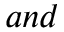<formula> <loc_0><loc_0><loc_500><loc_500>a n d</formula> 